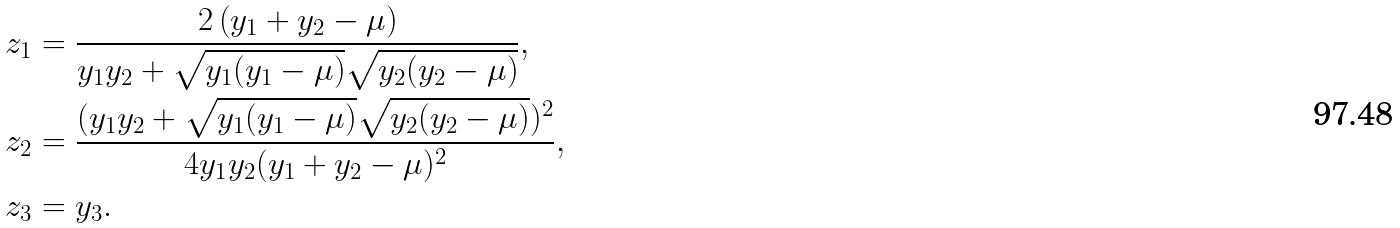Convert formula to latex. <formula><loc_0><loc_0><loc_500><loc_500>z _ { 1 } & = \frac { 2 \left ( y _ { 1 } + y _ { 2 } - \mu \right ) } { y _ { 1 } y _ { 2 } + \sqrt { y _ { 1 } ( y _ { 1 } - \mu ) } \sqrt { y _ { 2 } ( y _ { 2 } - \mu ) } } , \\ z _ { 2 } & = \frac { ( y _ { 1 } y _ { 2 } + \sqrt { y _ { 1 } ( y _ { 1 } - \mu ) } \sqrt { y _ { 2 } ( y _ { 2 } - \mu ) } ) ^ { 2 } } { 4 y _ { 1 } y _ { 2 } ( y _ { 1 } + y _ { 2 } - \mu ) ^ { 2 } } , \\ z _ { 3 } & = y _ { 3 } .</formula> 